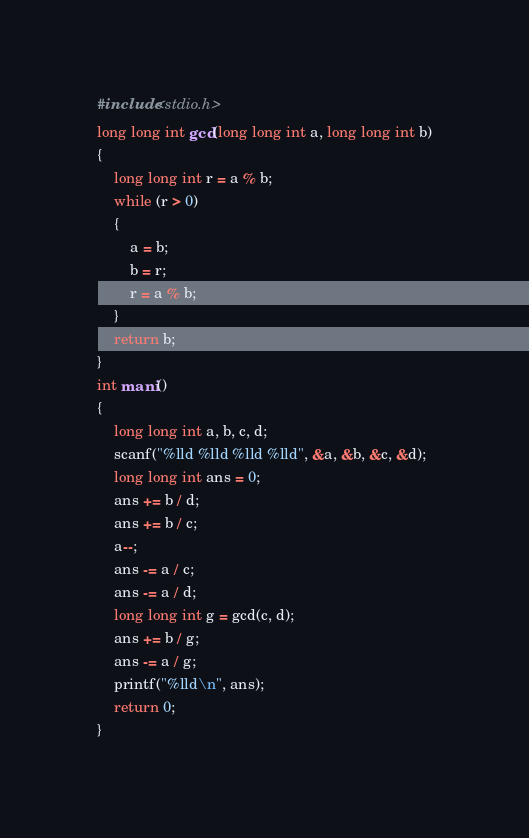Convert code to text. <code><loc_0><loc_0><loc_500><loc_500><_C_>#include<stdio.h>
long long int gcd(long long int a, long long int b)
{
	long long int r = a % b;
	while (r > 0)
	{
		a = b;
		b = r;
		r = a % b;
	}
	return b;
}
int mani()
{
	long long int a, b, c, d;
	scanf("%lld %lld %lld %lld", &a, &b, &c, &d);
	long long int ans = 0;
	ans += b / d;
	ans += b / c;
	a--;
	ans -= a / c;
	ans -= a / d;
	long long int g = gcd(c, d);
	ans += b / g;
	ans -= a / g;
	printf("%lld\n", ans);
	return 0;
}</code> 